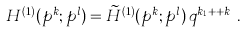<formula> <loc_0><loc_0><loc_500><loc_500>H ^ { ( 1 ) } ( p ^ { k } ; p ^ { l } ) = \widetilde { H } ^ { ( 1 ) } ( p ^ { k } ; p ^ { l } ) \, q ^ { k _ { 1 } + \cdots + k _ { r } } .</formula> 